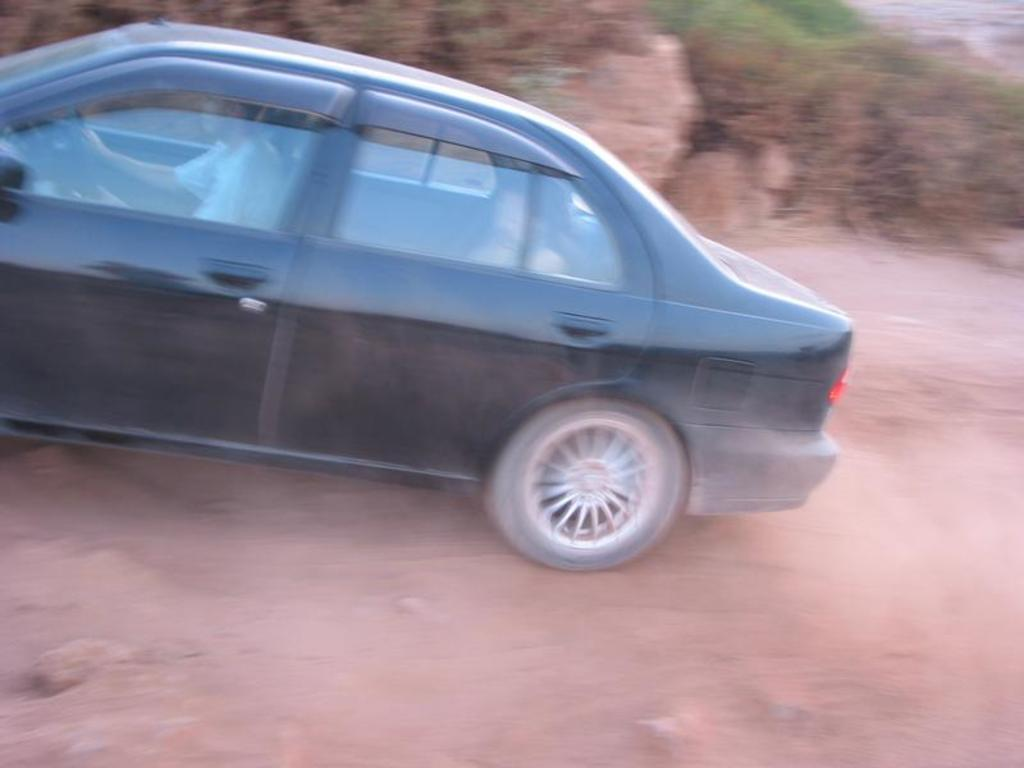What is the person doing in the image? The person is in a car in the image. Where is the car located? The car is on the road in the image. What can be seen in the background of the image? There are trees and plants in the background of the image. What type of lipstick is the person wearing in the image? There is no information about the person's lipstick or any makeup in the image. 